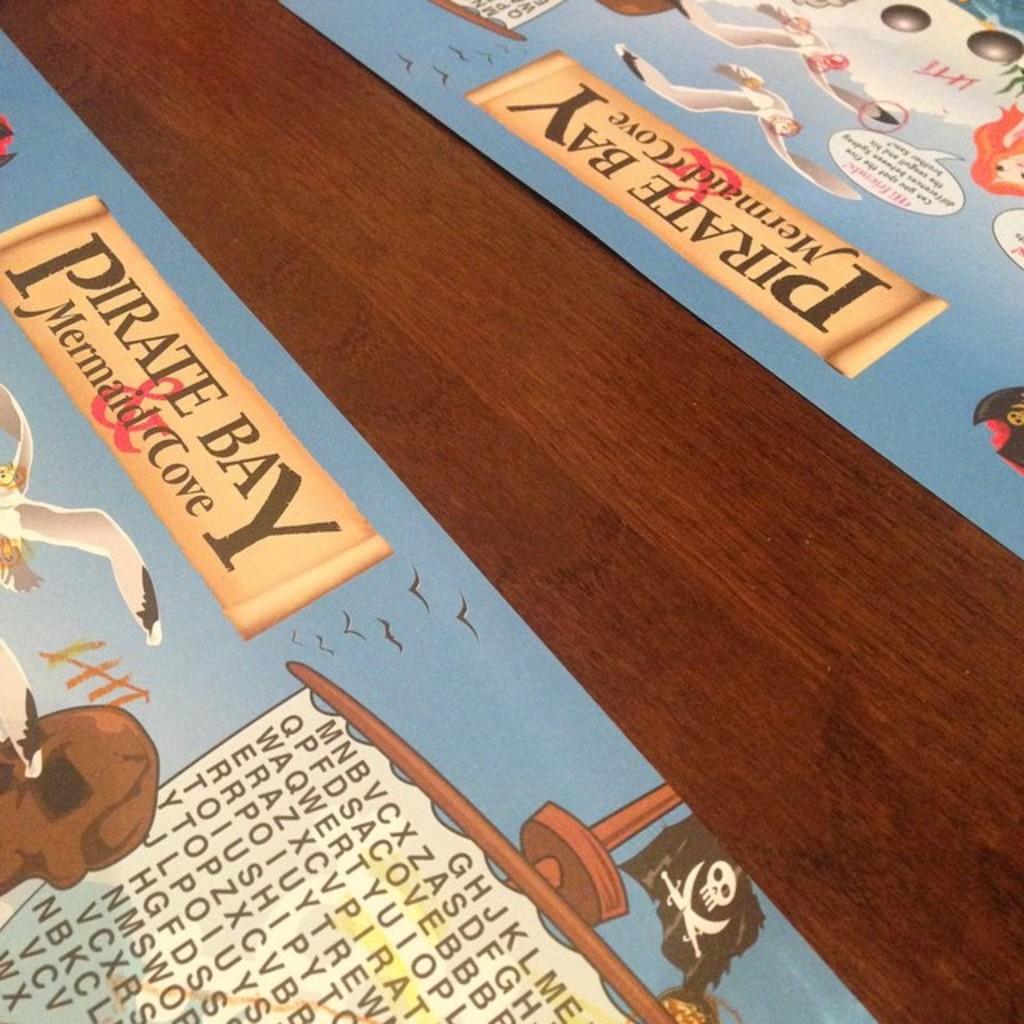Is this talking about pirate bay?
Your answer should be compact. Yes. What cove is written on the paper mat?
Offer a very short reply. Mermaid. 